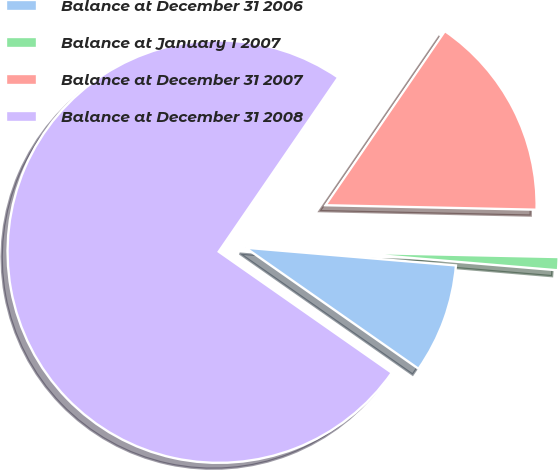Convert chart to OTSL. <chart><loc_0><loc_0><loc_500><loc_500><pie_chart><fcel>Balance at December 31 2006<fcel>Balance at January 1 2007<fcel>Balance at December 31 2007<fcel>Balance at December 31 2008<nl><fcel>8.38%<fcel>1.0%<fcel>15.77%<fcel>74.85%<nl></chart> 